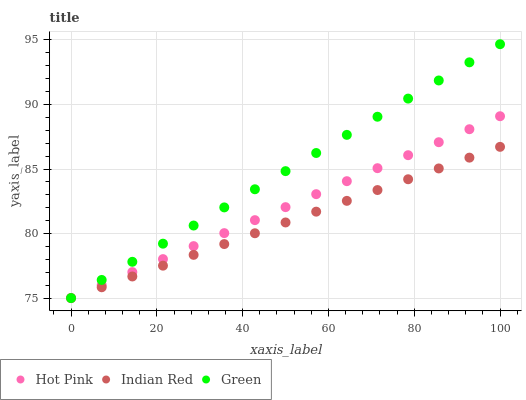Does Indian Red have the minimum area under the curve?
Answer yes or no. Yes. Does Green have the maximum area under the curve?
Answer yes or no. Yes. Does Green have the minimum area under the curve?
Answer yes or no. No. Does Indian Red have the maximum area under the curve?
Answer yes or no. No. Is Indian Red the smoothest?
Answer yes or no. Yes. Is Hot Pink the roughest?
Answer yes or no. Yes. Is Green the smoothest?
Answer yes or no. No. Is Green the roughest?
Answer yes or no. No. Does Hot Pink have the lowest value?
Answer yes or no. Yes. Does Green have the highest value?
Answer yes or no. Yes. Does Indian Red have the highest value?
Answer yes or no. No. Does Hot Pink intersect Green?
Answer yes or no. Yes. Is Hot Pink less than Green?
Answer yes or no. No. Is Hot Pink greater than Green?
Answer yes or no. No. 